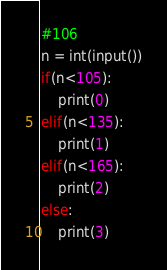Convert code to text. <code><loc_0><loc_0><loc_500><loc_500><_Python_>#106
n = int(input())
if(n<105):
    print(0)
elif(n<135):
    print(1)
elif(n<165):
    print(2)
else:
    print(3)</code> 